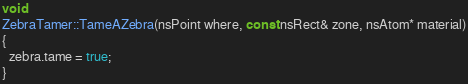Convert code to text. <code><loc_0><loc_0><loc_500><loc_500><_C_>void
ZebraTamer::TameAZebra(nsPoint where, const nsRect& zone, nsAtom* material)
{
  zebra.tame = true;
}
</code> 